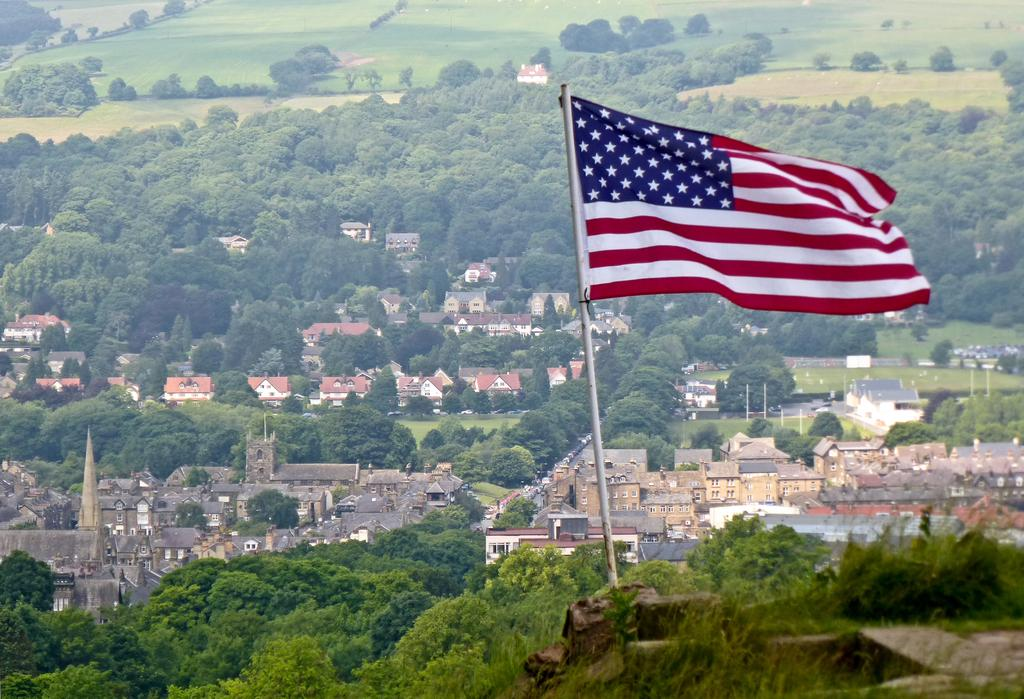What can be seen flying in the image? There is a flag in the image. What type of vegetation is present in the image? There are trees in the image. What type of structures are visible in the image? There are buildings in the image. What type of surface is visible in the image? There is grass on the surface in the image. What type of berry is growing on the flag in the image? There are no berries present in the image, and the flag is not a plant that can grow berries. What type of home is visible in the image? There is no home visible in the image; only a flag, trees, buildings, and grass are present. 